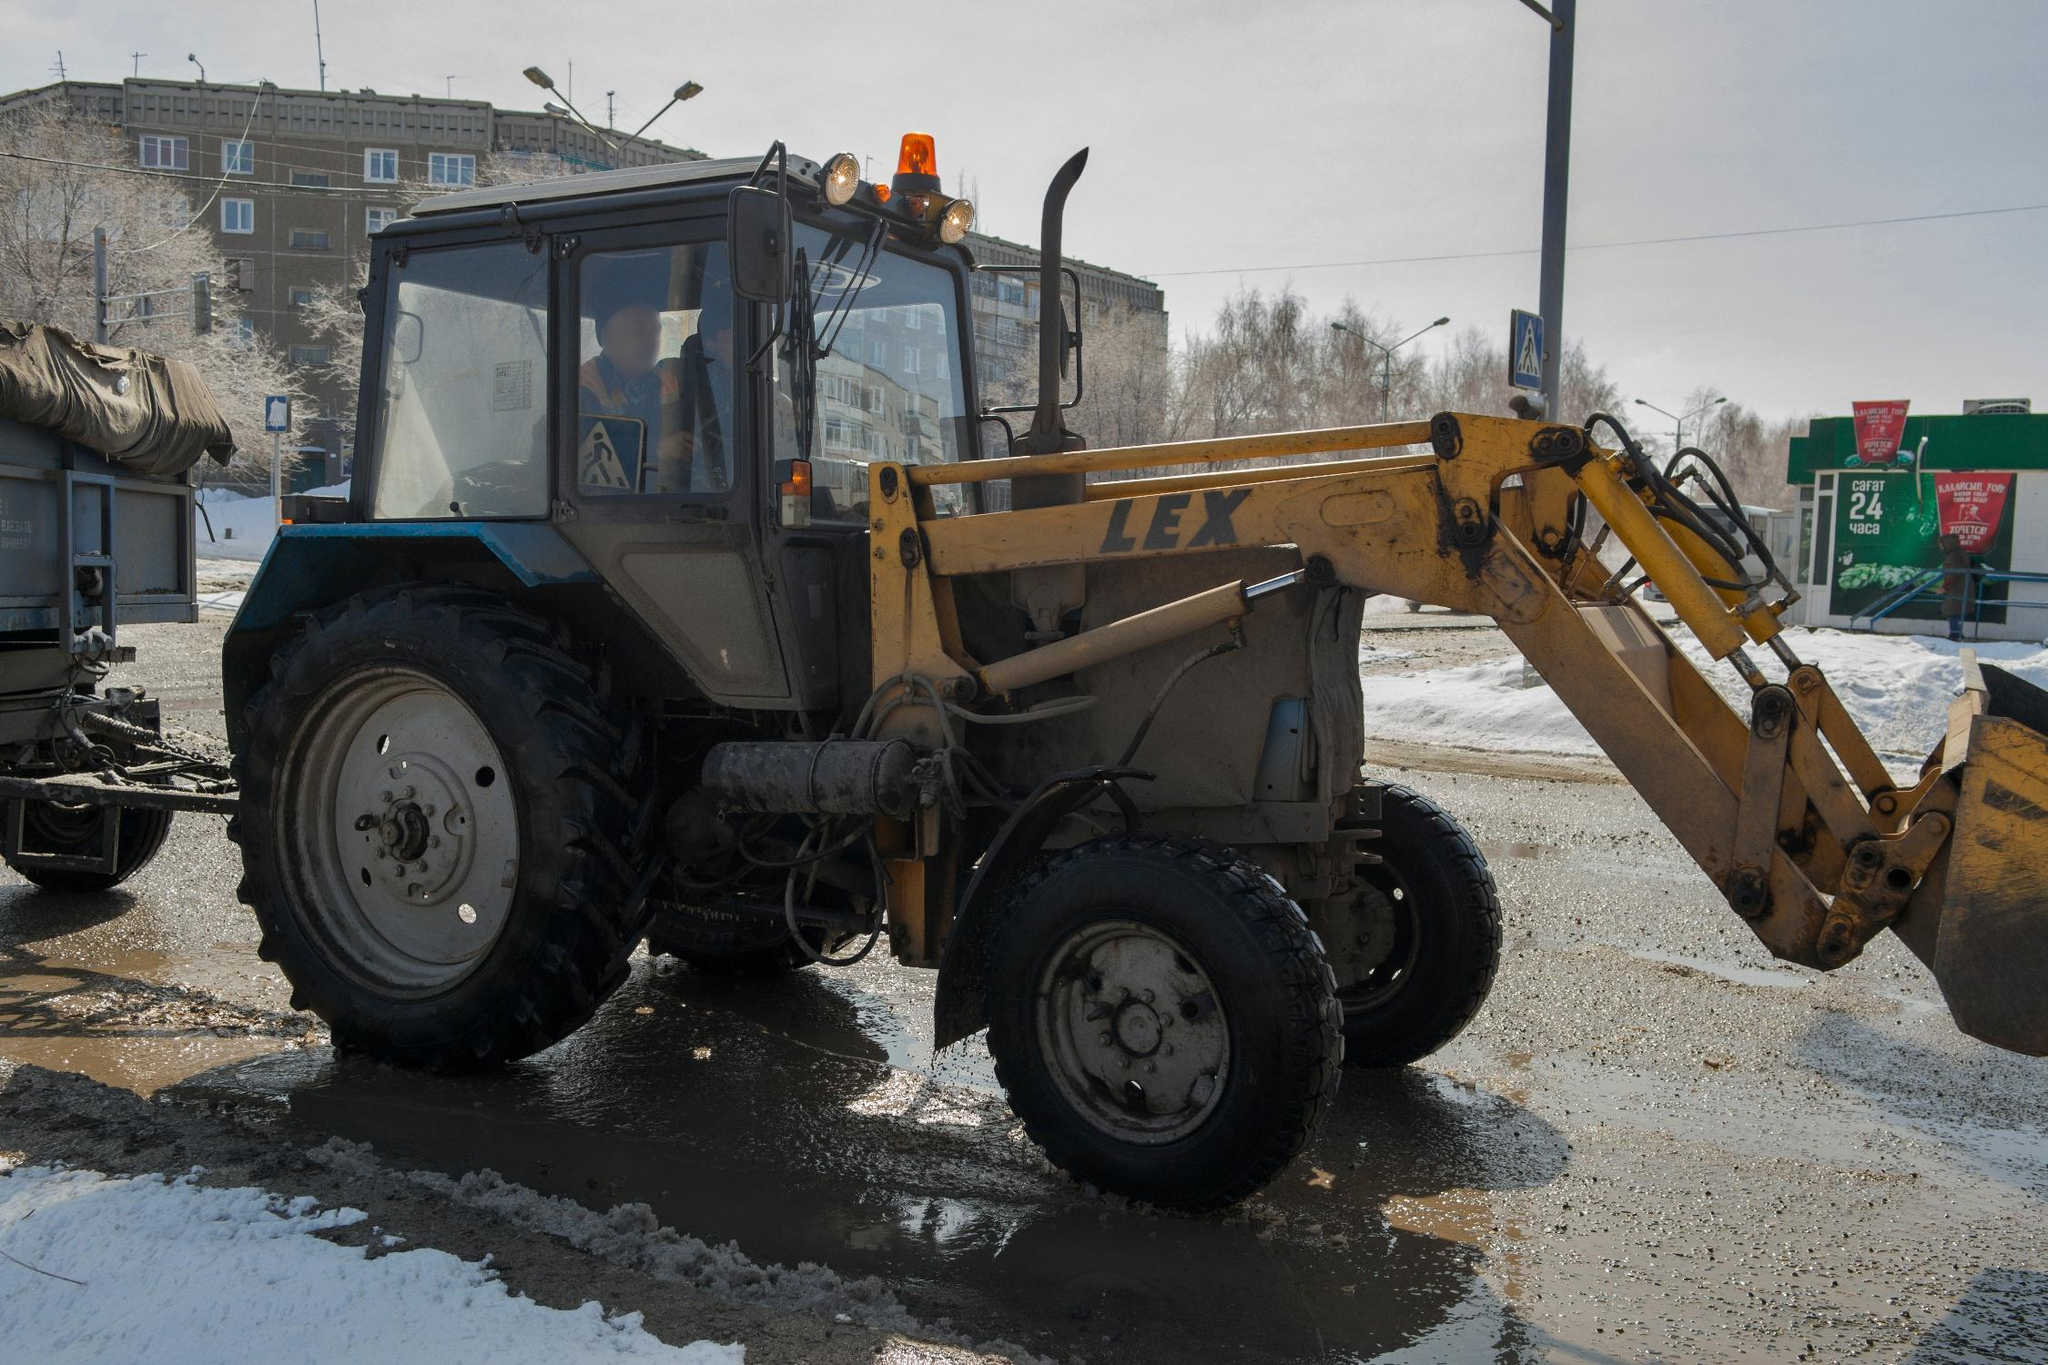Could you describe the activities in the background of the scene? In the background, we observe a building with various advertisements including a noticeable green billboard which might be offering local services or products. The presence of these elements suggests an active commercial zone where advertisements aim to catch the eye of commuters and residents alike, reinforcing the multipurpose nature of this urban area. What does the presence of these advertisements indicate about this neighborhood? The advertisements suggest that the neighborhood serves a significant commercial function. They potentially attract and inform local consumers and commuters about available services or products, contributing to the economic vibrancy of the area. This dynamic can often lead to a neighborhood being a focal point not just for commerce but also for social interactions and community life. 